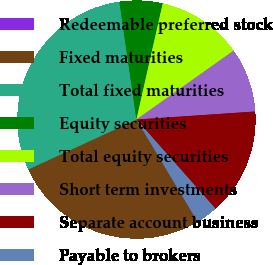Convert chart. <chart><loc_0><loc_0><loc_500><loc_500><pie_chart><fcel>Redeemable preferred stock<fcel>Fixed maturities<fcel>Total fixed maturities<fcel>Equity securities<fcel>Total equity securities<fcel>Short term investments<fcel>Separate account business<fcel>Payable to brokers<nl><fcel>0.04%<fcel>26.69%<fcel>29.59%<fcel>5.84%<fcel>11.64%<fcel>8.74%<fcel>14.54%<fcel>2.94%<nl></chart> 